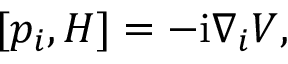<formula> <loc_0><loc_0><loc_500><loc_500>\begin{array} { r } { [ p _ { i } , H ] = - i \nabla _ { i } V , } \end{array}</formula> 